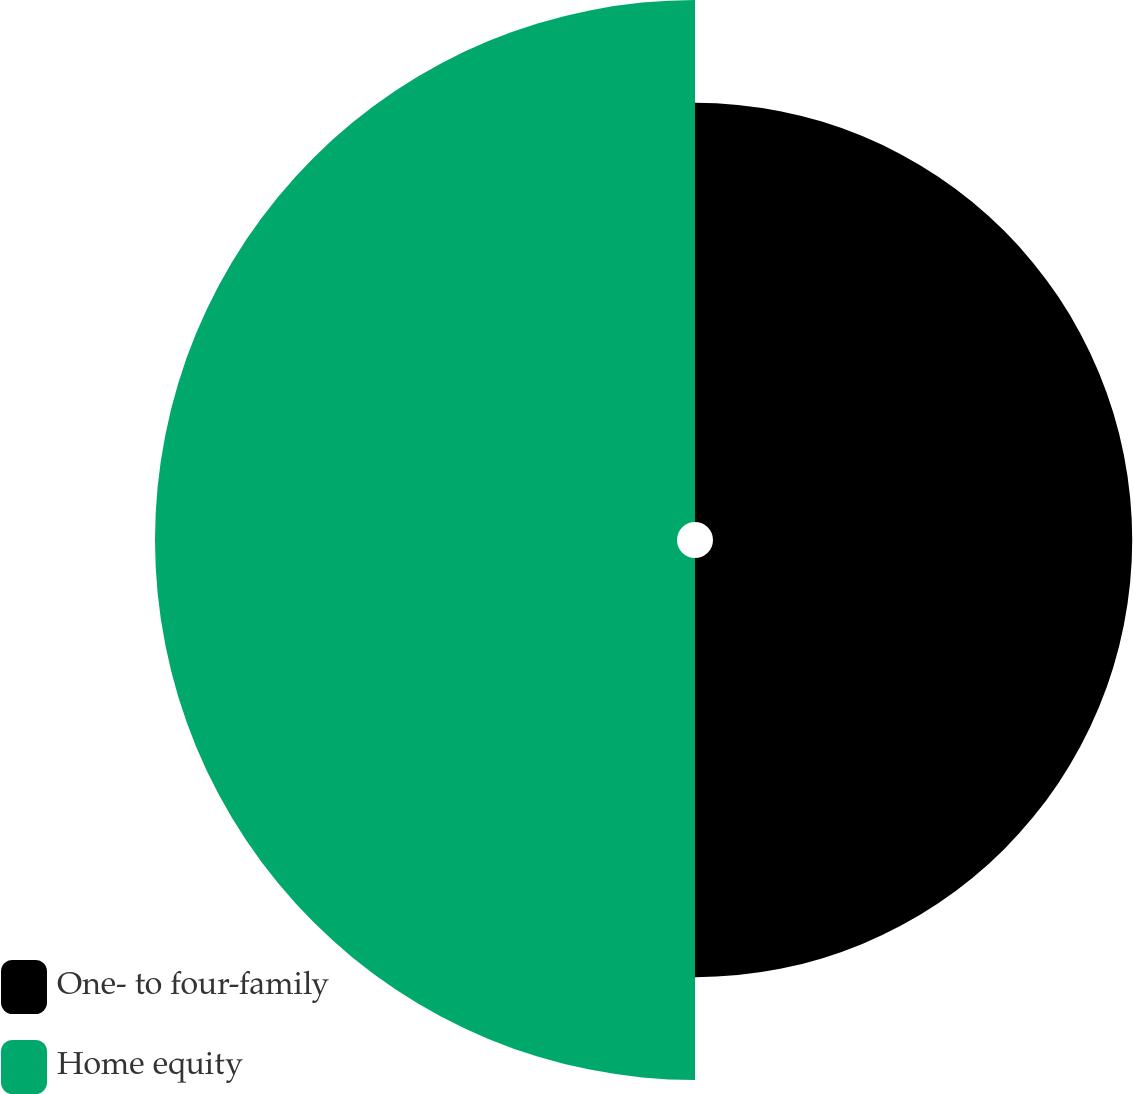<chart> <loc_0><loc_0><loc_500><loc_500><pie_chart><fcel>One- to four-family<fcel>Home equity<nl><fcel>44.54%<fcel>55.46%<nl></chart> 